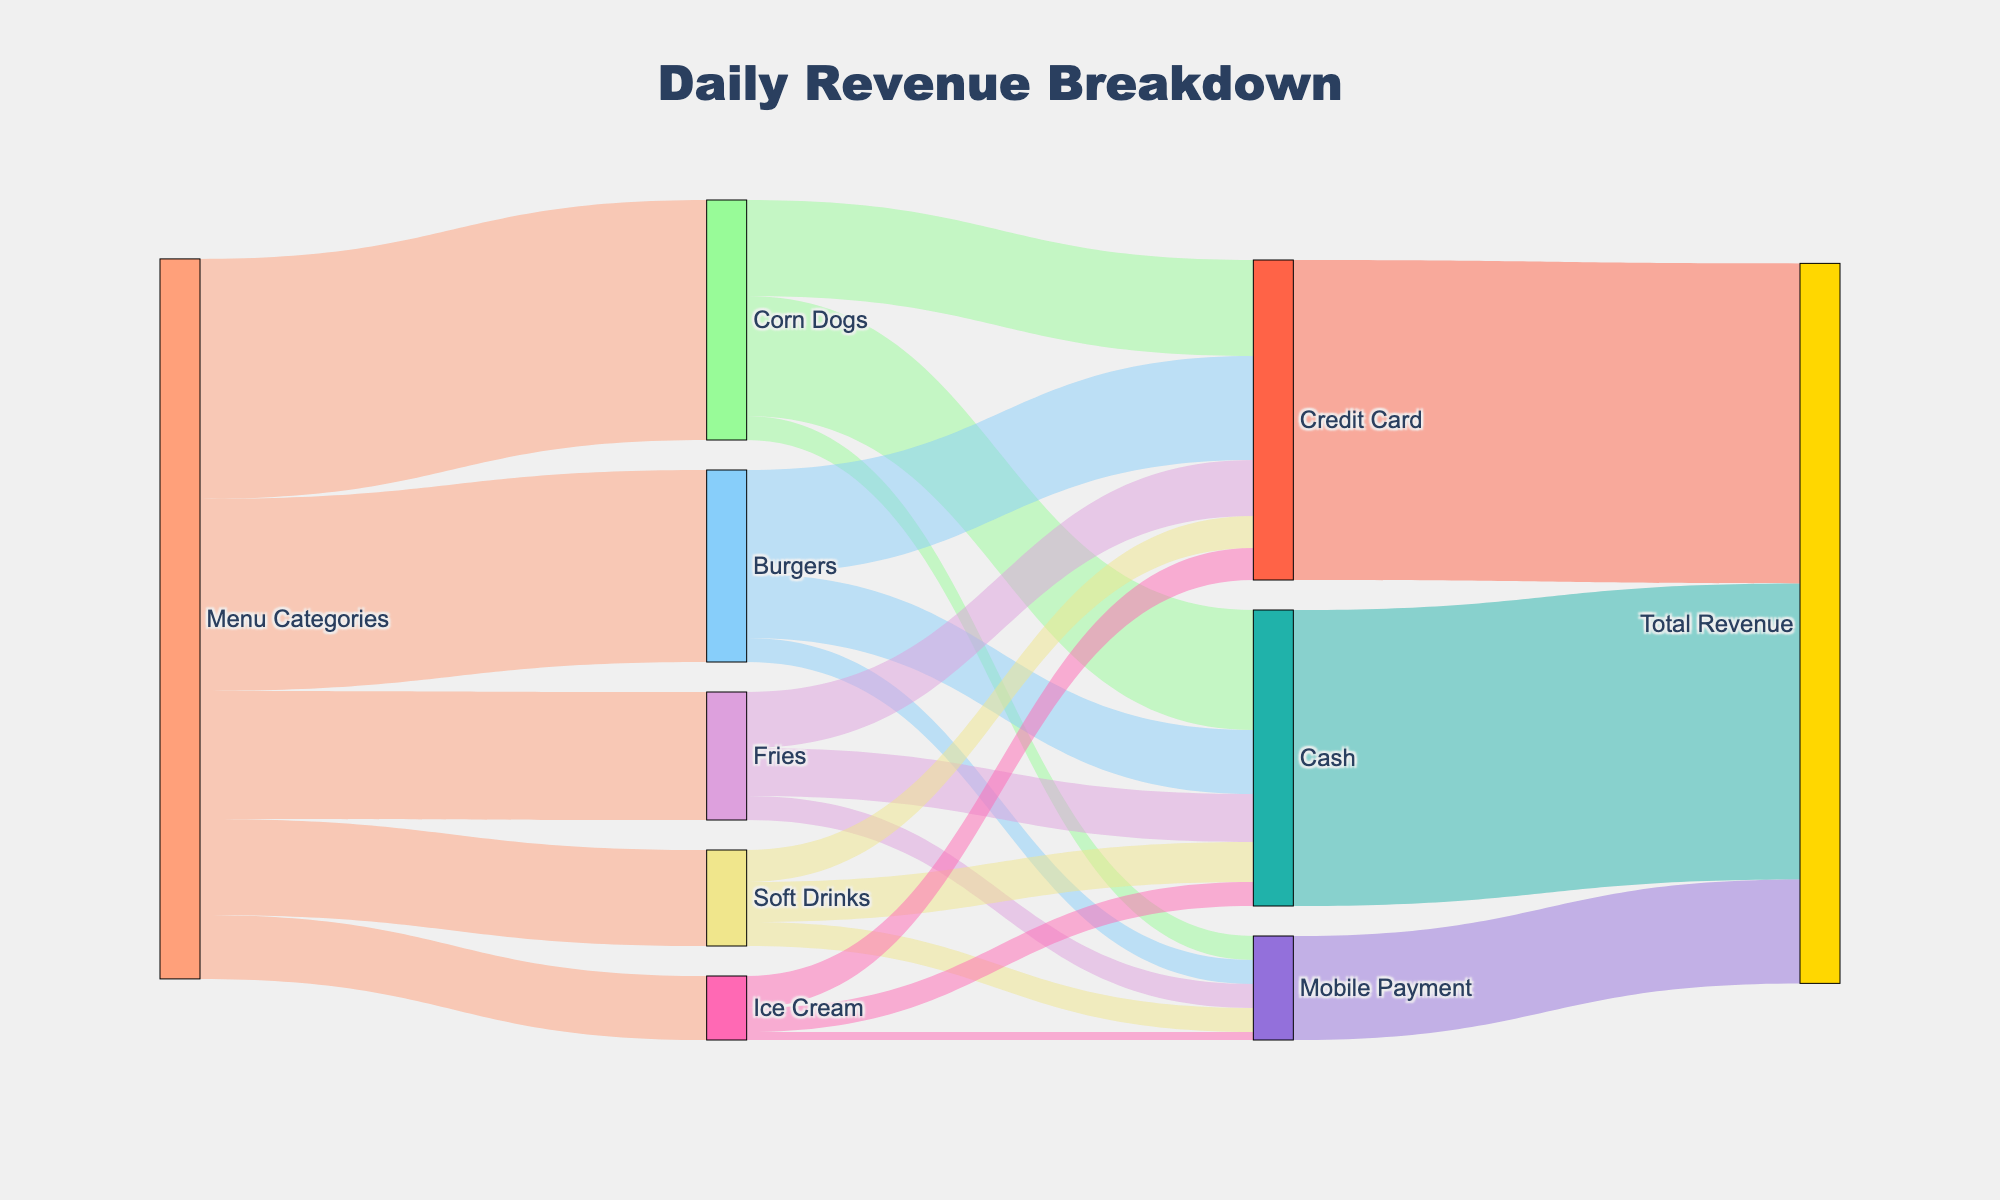What is the title of the figure? The title is shown at the top center of the diagram and it indicates what the Sankey Diagram is about.
Answer: Daily Revenue Breakdown What color represents Burgers in the diagram? The color of Burgers can be directly observed from the diagram's legend or node color.
Answer: Light blue Which menu category has the highest revenue? Look at the connections from "Menu Categories" to each menu item and compare the size of the flows. Corn Dogs have the largest flow value, indicating the highest revenue.
Answer: Corn Dogs How much revenue did Cash contribute to the Total Revenue? Follow the flow from Cash to the Total Revenue and sum the values corresponding to Cash.
Answer: 185 What is the total revenue contributed by Corn Dogs? Sum the values of all the payment methods that connect to Corn Dogs (75 + 60 + 15).
Answer: 150 Which payment method is least used across all menu categories? Look at the flows from menu categories to each payment method; Mobile Payment has the smallest flow values overall.
Answer: Mobile Payment What is the difference in revenue between Credit Card and Cash payments for Soft Drinks? For Soft Drinks, subtract the Cash revenue from the Credit Card revenue using the values of their respective flows (20 - 25).
Answer: 5 Which category received the most revenue through Mobile Payment? Compare all the flows connecting each menu category to Mobile Payment; Corn Dogs have the largest value.
Answer: Corn Dogs What is the combined revenue of Burgers and Fries through Credit Card? Add the values of Credit Card flows for Burgers and Fries (65 + 35).
Answer: 100 How does the revenue for Ice Cream compare between Cash and Credit Card? Compare the flows from Ice Cream to both Cash and Credit Card directly; Ice Cream received 15 from Cash and 20 from Credit Card.
Answer: More from Credit Card What fraction of the total revenue is made up by Mobile Payment? Sum the total revenue from all payment methods (185+200+65=450), then divide the Mobile Payment revenue by this sum (65/450) and convert to a percentage.
Answer: Approx. 14.4% 